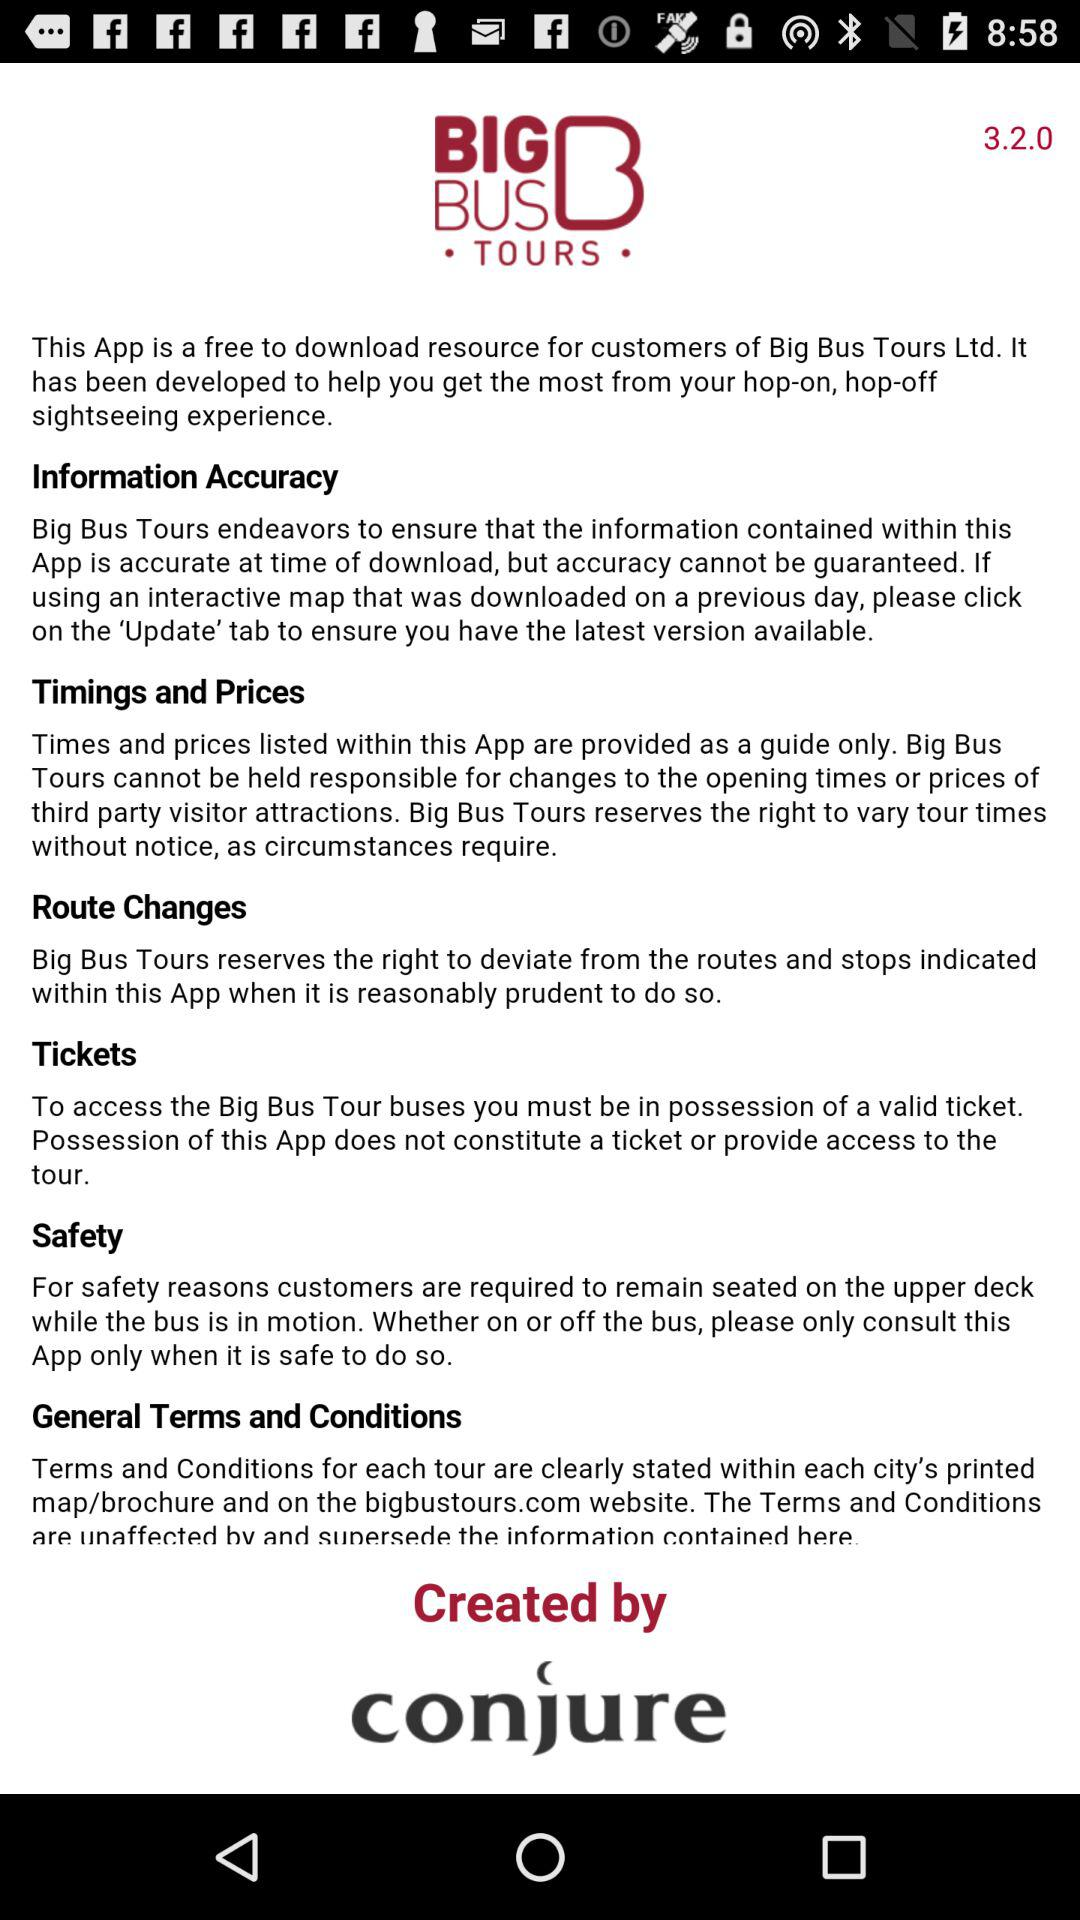What is the information on the accuracy of "Big Bus Tours"? The information on the accuracy of "Big Bus Tours" is "Big Bus Tours endeavors to ensure that the information contained within this App is accurate at time of download, but accuracy cannot be guaranteed. If using an interactive map that was downloaded on a previous day, please click on the 'Update' tab to ensure you have the latest version available.". 